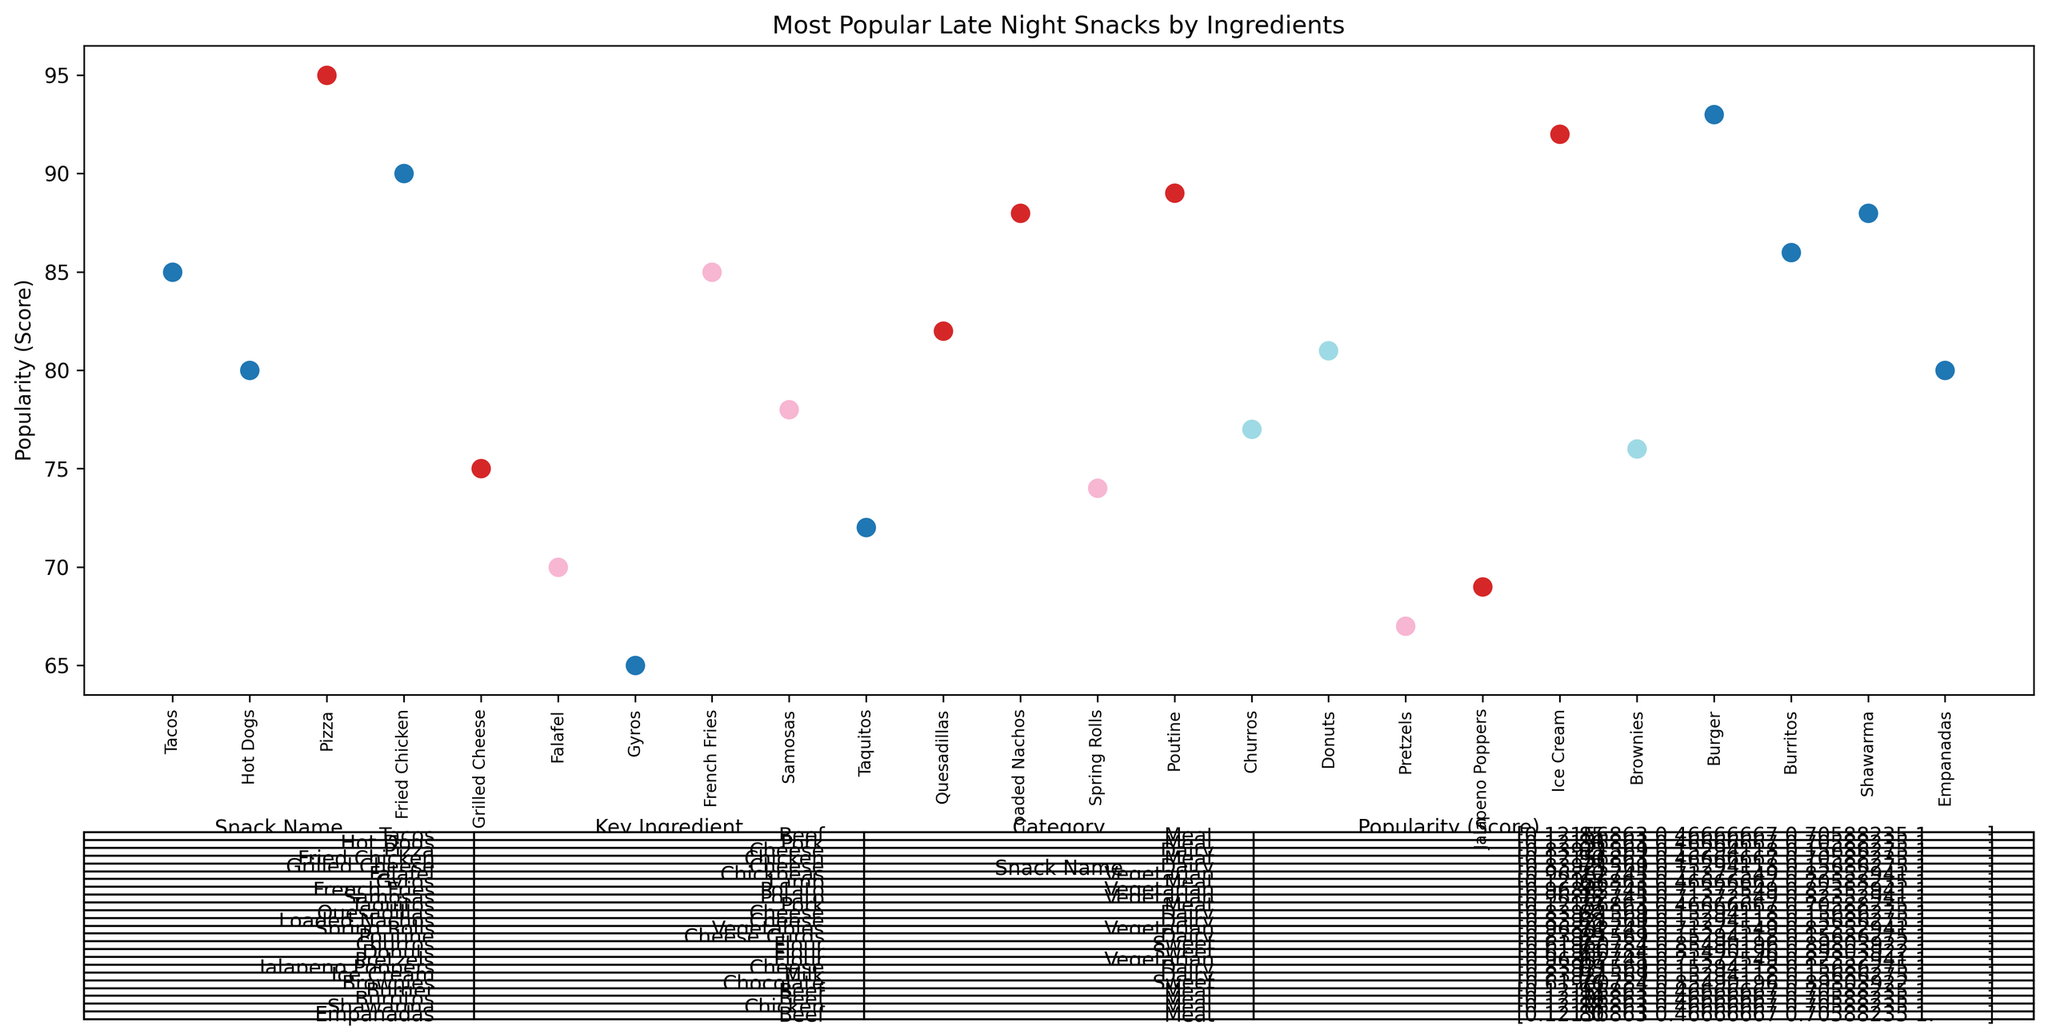How many categories of late-night snacks are there in the chart? First, look at the 'Category' column in the table displayed in the plot. Next, count each unique category listed.
Answer: 4 Which snack has the highest popularity score? Check the 'Popularity (Score)' column for the highest value. Correspond it to the 'Snack Name'.
Answer: Pizza What is the average popularity score for Meat snacks? Identify all snacks under the 'Meat' category. Extract their popularity scores: (85, 80, 90, 65, 72, 93, 86, 88, 80). Sum these values (85 + 80 + 90 + 65 + 72 + 93 + 86 + 88 + 80 = 739) and divide by the number of snacks (739 / 9).
Answer: 82.11 Which is more popular, French Fries or Samosas? Compare the 'Popularity (Score)' of French Fries (85) with Samosas (78). Since 85 > 78, French Fries is more popular.
Answer: French Fries What is the total popularity score for Dairy category snacks? Identify Dairy snacks and sum their scores: (95, 75, 82, 88, 89, 69, 92). Sum these scores (95 + 75 + 82 + 88 + 89 + 69 + 92 = 590).
Answer: 590 Which category does the snack with the lowest popularity score belong to? Identify the lowest popularity score in the 'Popularity (Score)' column. The snack with the lowest score is Gyros (65). The corresponding 'Category' is Meat.
Answer: Meat How many snacks have a popularity score above 80? Count the number of snacks with a 'Popularity (Score)' greater than 80.
Answer: 11 Which is more popular, a Dairy snack or a Meat snack on average? Calculate the average popularity score for Dairy: (95 + 75 + 82 + 88 + 89 + 69 + 92) / 7 = 84.29. For Meat: (85 + 80 + 90 + 65 + 72 + 93 + 86 + 88 + 80) / 9 = 82.11. Dairy's average score is higher than Meat's.
Answer: Dairy What snack is evenly visualized in terms of height but falls into a different category compared to Tacos? Tacos have a height that corresponds to a score of 85. Look for other snacks with similar scores: French Fries also has a score of 85 and falls into the Vegetarian category.
Answer: French Fries 